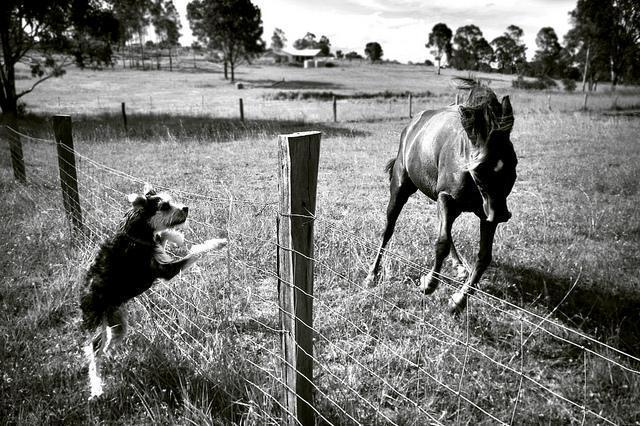How many clock faces are visible?
Give a very brief answer. 0. 